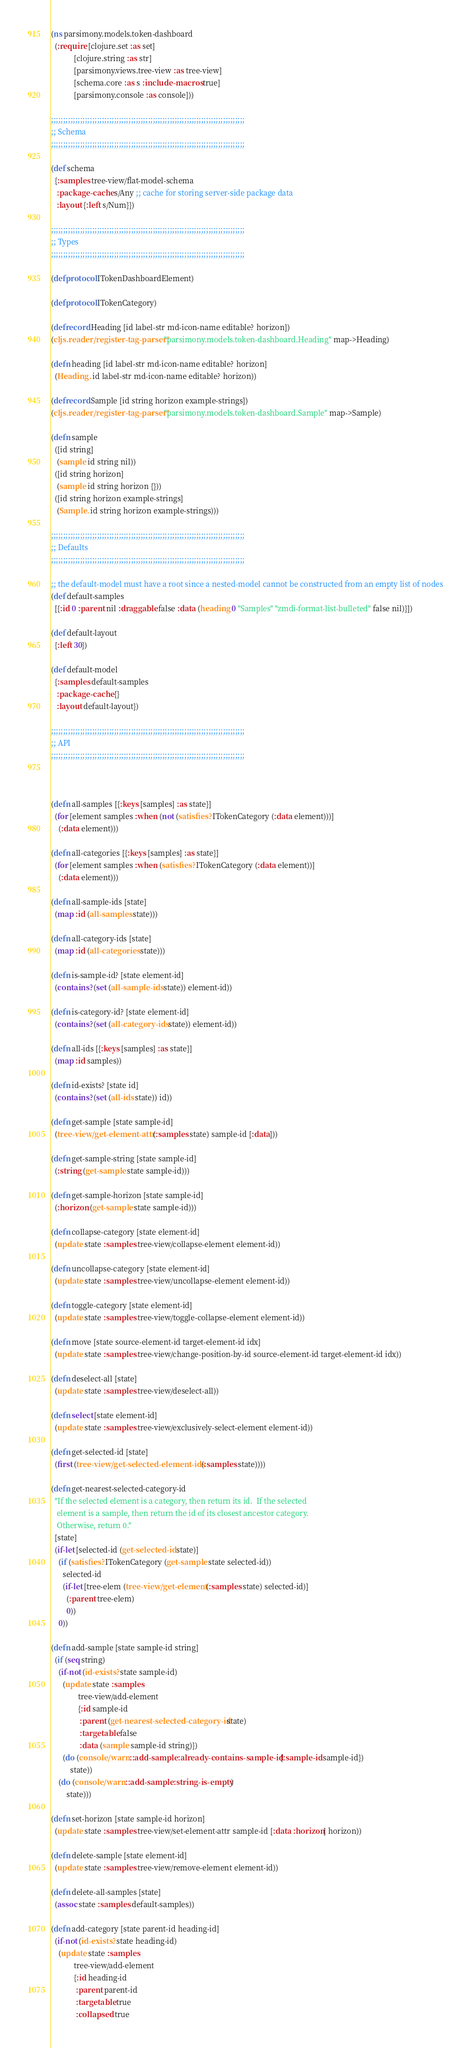Convert code to text. <code><loc_0><loc_0><loc_500><loc_500><_Clojure_>(ns parsimony.models.token-dashboard
  (:require [clojure.set :as set]
            [clojure.string :as str]
            [parsimony.views.tree-view :as tree-view]
            [schema.core :as s :include-macros true]
            [parsimony.console :as console]))

;;;;;;;;;;;;;;;;;;;;;;;;;;;;;;;;;;;;;;;;;;;;;;;;;;;;;;;;;;;;;;;;;;;;;;;;;;;;;;;;
;; Schema
;;;;;;;;;;;;;;;;;;;;;;;;;;;;;;;;;;;;;;;;;;;;;;;;;;;;;;;;;;;;;;;;;;;;;;;;;;;;;;;;

(def schema
  {:samples tree-view/flat-model-schema
   :package-cache s/Any ;; cache for storing server-side package data
   :layout {:left s/Num}})

;;;;;;;;;;;;;;;;;;;;;;;;;;;;;;;;;;;;;;;;;;;;;;;;;;;;;;;;;;;;;;;;;;;;;;;;;;;;;;;;
;; Types
;;;;;;;;;;;;;;;;;;;;;;;;;;;;;;;;;;;;;;;;;;;;;;;;;;;;;;;;;;;;;;;;;;;;;;;;;;;;;;;;

(defprotocol ITokenDashboardElement)

(defprotocol ITokenCategory)

(defrecord Heading [id label-str md-icon-name editable? horizon])
(cljs.reader/register-tag-parser! "parsimony.models.token-dashboard.Heading" map->Heading)

(defn heading [id label-str md-icon-name editable? horizon]
  (Heading. id label-str md-icon-name editable? horizon))

(defrecord Sample [id string horizon example-strings])
(cljs.reader/register-tag-parser! "parsimony.models.token-dashboard.Sample" map->Sample)

(defn sample
  ([id string]
   (sample id string nil))
  ([id string horizon]
   (sample id string horizon {}))
  ([id string horizon example-strings]
   (Sample. id string horizon example-strings)))

;;;;;;;;;;;;;;;;;;;;;;;;;;;;;;;;;;;;;;;;;;;;;;;;;;;;;;;;;;;;;;;;;;;;;;;;;;;;;;;;
;; Defaults
;;;;;;;;;;;;;;;;;;;;;;;;;;;;;;;;;;;;;;;;;;;;;;;;;;;;;;;;;;;;;;;;;;;;;;;;;;;;;;;;

;; the default-model must have a root since a nested-model cannot be constructed from an empty list of nodes
(def default-samples
  [{:id 0 :parent nil :draggable false :data (heading 0 "Samples" "zmdi-format-list-bulleted" false nil)}])

(def default-layout
  {:left 30})

(def default-model
  {:samples default-samples
   :package-cache {}
   :layout default-layout})

;;;;;;;;;;;;;;;;;;;;;;;;;;;;;;;;;;;;;;;;;;;;;;;;;;;;;;;;;;;;;;;;;;;;;;;;;;;;;;;;
;; API
;;;;;;;;;;;;;;;;;;;;;;;;;;;;;;;;;;;;;;;;;;;;;;;;;;;;;;;;;;;;;;;;;;;;;;;;;;;;;;;;



(defn all-samples [{:keys [samples] :as state}]
  (for [element samples :when (not (satisfies? ITokenCategory (:data element)))]
    (:data element)))

(defn all-categories [{:keys [samples] :as state}]
  (for [element samples :when (satisfies? ITokenCategory (:data element))]
    (:data element)))

(defn all-sample-ids [state]
  (map :id (all-samples state)))

(defn all-category-ids [state]
  (map :id (all-categories state)))

(defn is-sample-id? [state element-id]
  (contains? (set (all-sample-ids state)) element-id))

(defn is-category-id? [state element-id]
  (contains? (set (all-category-ids state)) element-id))

(defn all-ids [{:keys [samples] :as state}]
  (map :id samples))

(defn id-exists? [state id]
  (contains? (set (all-ids state)) id))

(defn get-sample [state sample-id]
  (tree-view/get-element-attr (:samples state) sample-id [:data]))

(defn get-sample-string [state sample-id]
  (:string (get-sample state sample-id)))

(defn get-sample-horizon [state sample-id]
  (:horizon (get-sample state sample-id)))

(defn collapse-category [state element-id]
  (update state :samples tree-view/collapse-element element-id))

(defn uncollapse-category [state element-id]
  (update state :samples tree-view/uncollapse-element element-id))

(defn toggle-category [state element-id]
  (update state :samples tree-view/toggle-collapse-element element-id))

(defn move [state source-element-id target-element-id idx]
  (update state :samples tree-view/change-position-by-id source-element-id target-element-id idx))

(defn deselect-all [state]
  (update state :samples tree-view/deselect-all))

(defn select [state element-id]
  (update state :samples tree-view/exclusively-select-element element-id))

(defn get-selected-id [state]
  (first (tree-view/get-selected-element-ids (:samples state))))

(defn get-nearest-selected-category-id
  "If the selected element is a category, then return its id.  If the selected
   element is a sample, then return the id of its closest ancestor category.
   Otherwise, return 0."
  [state]
  (if-let [selected-id (get-selected-id state)]
    (if (satisfies? ITokenCategory (get-sample state selected-id))
      selected-id
      (if-let [tree-elem (tree-view/get-element (:samples state) selected-id)]
        (:parent tree-elem)
        0))
    0))

(defn add-sample [state sample-id string]
  (if (seq string)
    (if-not (id-exists? state sample-id)
      (update state :samples
              tree-view/add-element
              {:id sample-id
               :parent (get-nearest-selected-category-id state)
               :targetable false
               :data (sample sample-id string)})
      (do (console/warn ::add-sample :already-contains-sample-id {:sample-id sample-id})
          state))
    (do (console/warn ::add-sample :string-is-empty)
        state)))

(defn set-horizon [state sample-id horizon]
  (update state :samples tree-view/set-element-attr sample-id [:data :horizon] horizon))

(defn delete-sample [state element-id]
  (update state :samples tree-view/remove-element element-id))

(defn delete-all-samples [state]
  (assoc state :samples default-samples))

(defn add-category [state parent-id heading-id]
  (if-not (id-exists? state heading-id)
    (update state :samples
            tree-view/add-element
            {:id heading-id
             :parent parent-id
             :targetable true
             :collapsed true</code> 